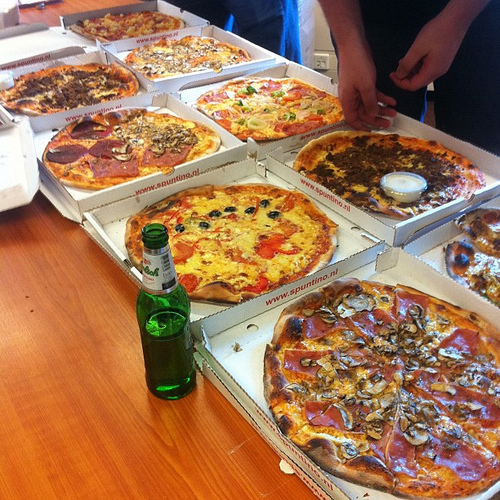What is in the box the sausage is to the right of? The box the sausage is to the right of contains pizza. 